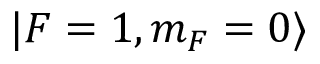<formula> <loc_0><loc_0><loc_500><loc_500>| F = 1 , m _ { F } = 0 \rangle</formula> 